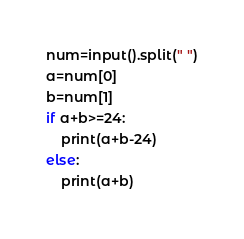Convert code to text. <code><loc_0><loc_0><loc_500><loc_500><_Python_>num=input().split(" ")
a=num[0]
b=num[1]
if a+b>=24:
	print(a+b-24)
else:
	print(a+b)</code> 